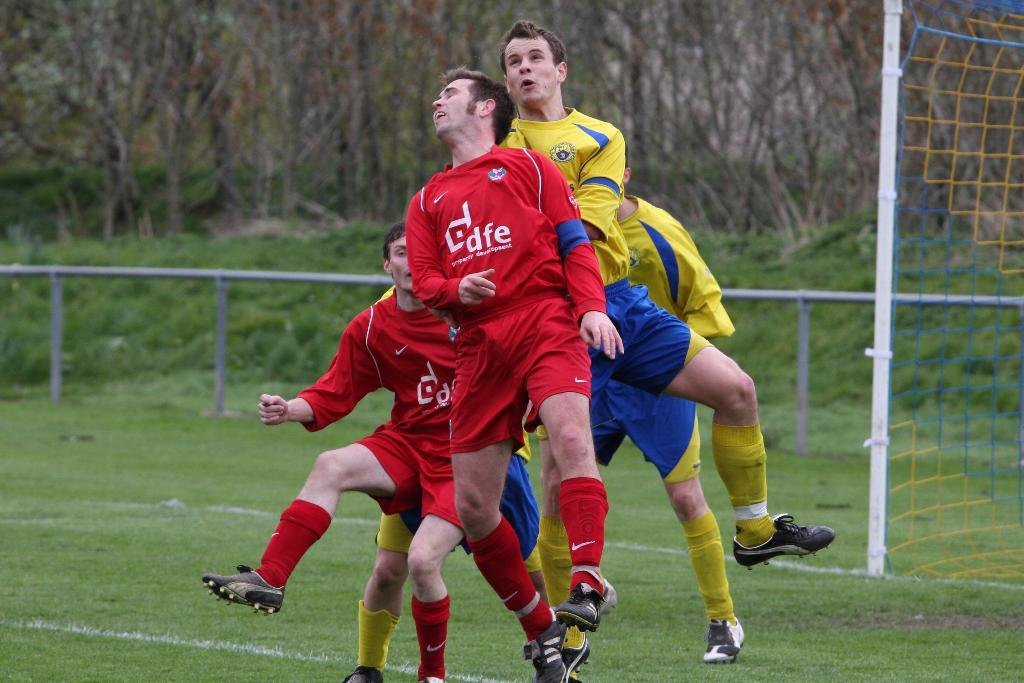<image>
Present a compact description of the photo's key features. A group of soccer players are scrambling over one another for the ball and the red players uniforms say dfe on the front. 